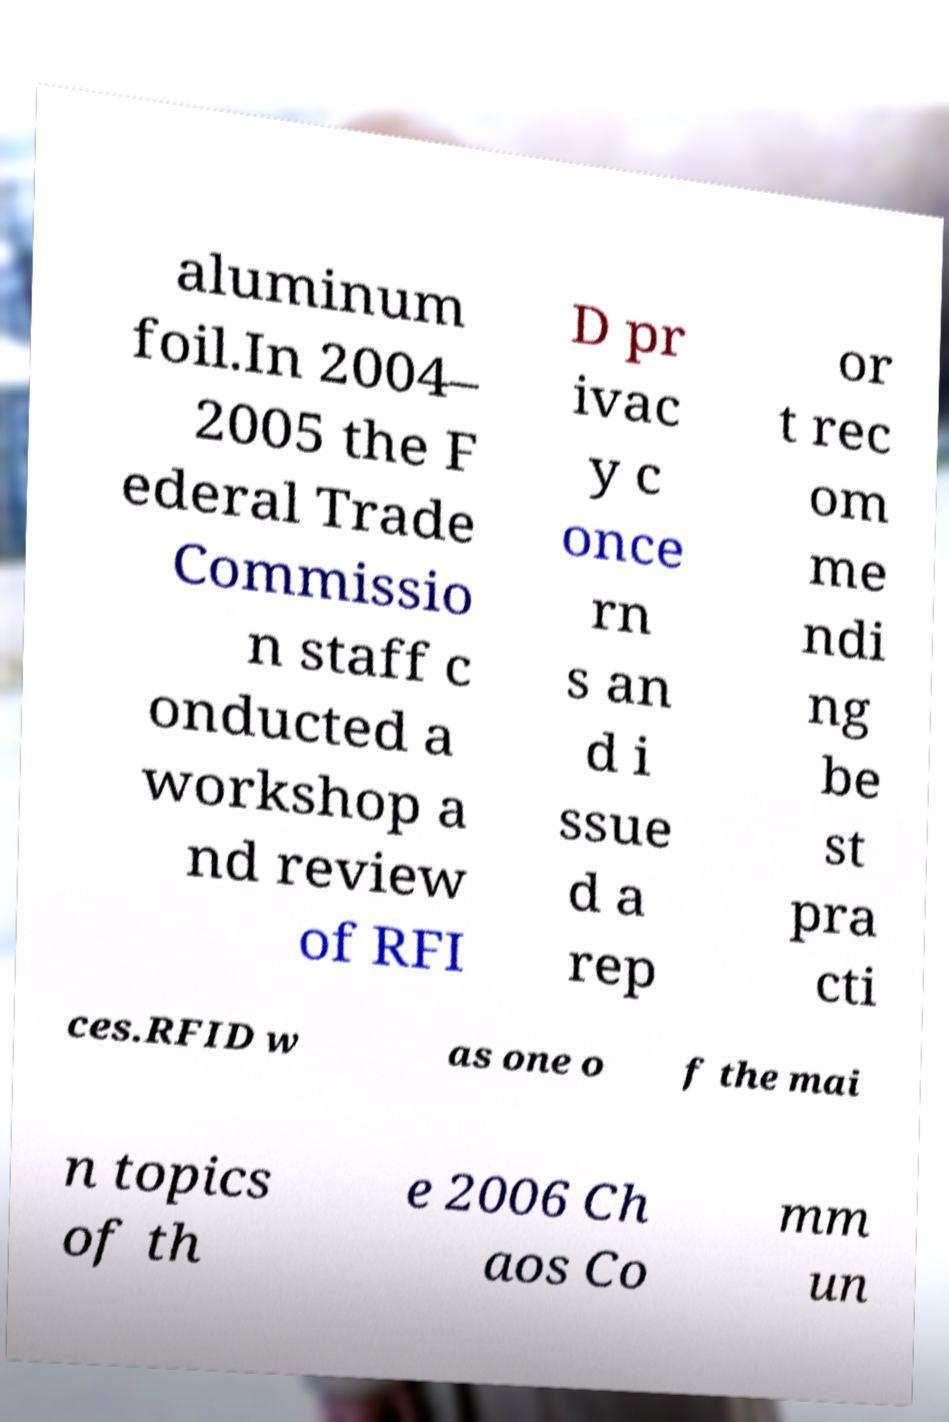Please read and relay the text visible in this image. What does it say? aluminum foil.In 2004– 2005 the F ederal Trade Commissio n staff c onducted a workshop a nd review of RFI D pr ivac y c once rn s an d i ssue d a rep or t rec om me ndi ng be st pra cti ces.RFID w as one o f the mai n topics of th e 2006 Ch aos Co mm un 